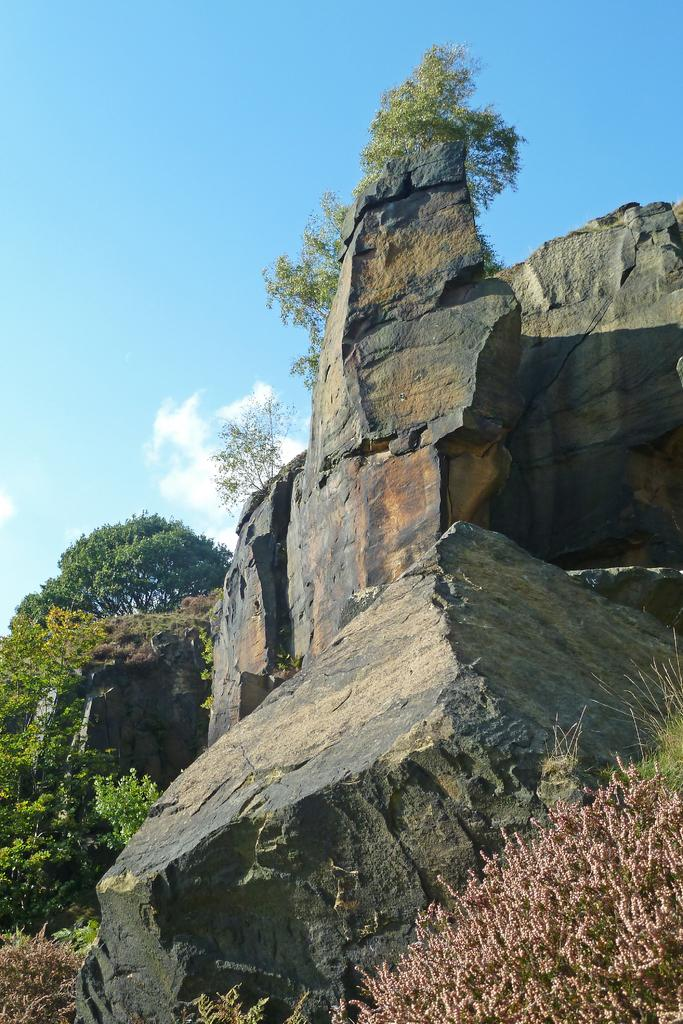What type of natural elements can be seen on the right side of the image? There are rocks on the right side of the image. What is located in the bottom corner of the image? There is a plant in the bottom corner of the image. What can be seen in the background of the image? There are trees, rocks, plants, and clouds visible in the background of the image. What type of fiction is being read by the button in the image? There is no button or fiction present in the image. How many sacks are visible in the image? There are no sacks visible in the image. 